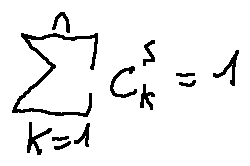<formula> <loc_0><loc_0><loc_500><loc_500>\sum \lim i t s _ { k = 1 } ^ { n } c _ { k } ^ { s } = 1</formula> 